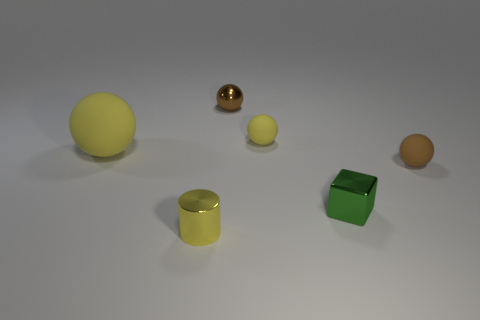Subtract 1 balls. How many balls are left? 3 Add 2 large gray metallic things. How many objects exist? 8 Subtract all cylinders. How many objects are left? 5 Add 4 small cyan rubber objects. How many small cyan rubber objects exist? 4 Subtract 0 red balls. How many objects are left? 6 Subtract all small rubber things. Subtract all tiny brown metallic objects. How many objects are left? 3 Add 5 yellow matte things. How many yellow matte things are left? 7 